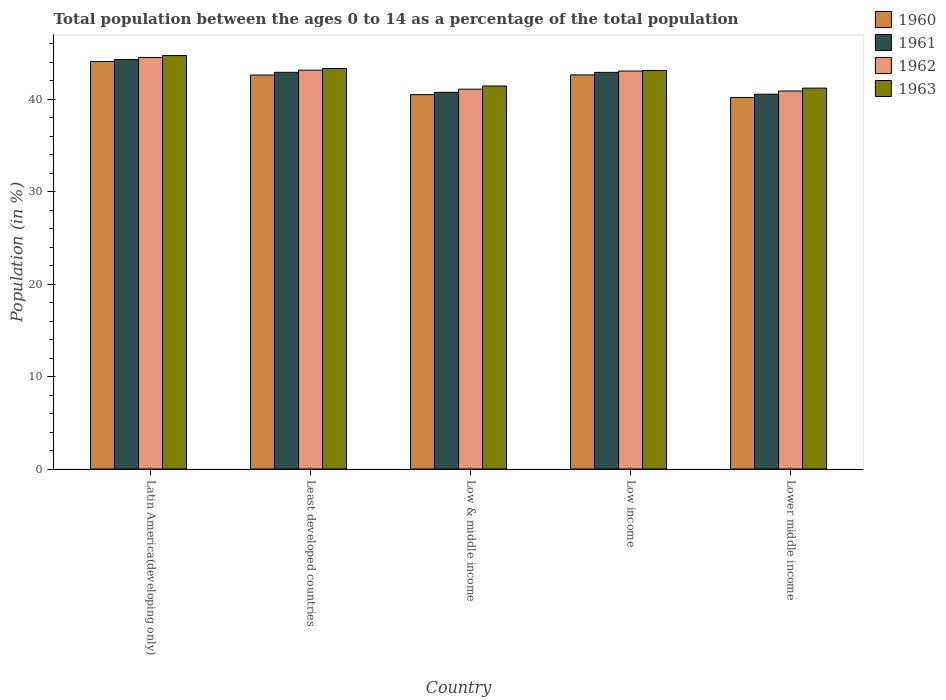How many different coloured bars are there?
Offer a very short reply. 4. What is the label of the 3rd group of bars from the left?
Ensure brevity in your answer.  Low & middle income. What is the percentage of the population ages 0 to 14 in 1963 in Least developed countries?
Provide a short and direct response. 43.34. Across all countries, what is the maximum percentage of the population ages 0 to 14 in 1963?
Your answer should be very brief. 44.74. Across all countries, what is the minimum percentage of the population ages 0 to 14 in 1962?
Ensure brevity in your answer.  40.9. In which country was the percentage of the population ages 0 to 14 in 1961 maximum?
Offer a very short reply. Latin America(developing only). In which country was the percentage of the population ages 0 to 14 in 1962 minimum?
Provide a succinct answer. Lower middle income. What is the total percentage of the population ages 0 to 14 in 1960 in the graph?
Your answer should be very brief. 210.1. What is the difference between the percentage of the population ages 0 to 14 in 1963 in Low & middle income and that in Lower middle income?
Your response must be concise. 0.23. What is the difference between the percentage of the population ages 0 to 14 in 1962 in Low & middle income and the percentage of the population ages 0 to 14 in 1963 in Least developed countries?
Your answer should be compact. -2.24. What is the average percentage of the population ages 0 to 14 in 1963 per country?
Give a very brief answer. 42.77. What is the difference between the percentage of the population ages 0 to 14 of/in 1961 and percentage of the population ages 0 to 14 of/in 1960 in Low income?
Ensure brevity in your answer.  0.27. In how many countries, is the percentage of the population ages 0 to 14 in 1962 greater than 18?
Ensure brevity in your answer.  5. What is the ratio of the percentage of the population ages 0 to 14 in 1963 in Latin America(developing only) to that in Low & middle income?
Keep it short and to the point. 1.08. Is the percentage of the population ages 0 to 14 in 1963 in Latin America(developing only) less than that in Least developed countries?
Offer a very short reply. No. What is the difference between the highest and the second highest percentage of the population ages 0 to 14 in 1961?
Provide a short and direct response. -1.38. What is the difference between the highest and the lowest percentage of the population ages 0 to 14 in 1961?
Give a very brief answer. 3.75. In how many countries, is the percentage of the population ages 0 to 14 in 1961 greater than the average percentage of the population ages 0 to 14 in 1961 taken over all countries?
Provide a short and direct response. 3. Is the sum of the percentage of the population ages 0 to 14 in 1963 in Least developed countries and Low income greater than the maximum percentage of the population ages 0 to 14 in 1962 across all countries?
Give a very brief answer. Yes. What does the 1st bar from the left in Lower middle income represents?
Your answer should be compact. 1960. What does the 2nd bar from the right in Low income represents?
Offer a very short reply. 1962. How many bars are there?
Make the answer very short. 20. How many countries are there in the graph?
Ensure brevity in your answer.  5. Does the graph contain any zero values?
Ensure brevity in your answer.  No. What is the title of the graph?
Your answer should be very brief. Total population between the ages 0 to 14 as a percentage of the total population. What is the label or title of the X-axis?
Your response must be concise. Country. What is the Population (in %) in 1960 in Latin America(developing only)?
Provide a succinct answer. 44.1. What is the Population (in %) in 1961 in Latin America(developing only)?
Your response must be concise. 44.31. What is the Population (in %) of 1962 in Latin America(developing only)?
Keep it short and to the point. 44.54. What is the Population (in %) of 1963 in Latin America(developing only)?
Your answer should be very brief. 44.74. What is the Population (in %) of 1960 in Least developed countries?
Ensure brevity in your answer.  42.63. What is the Population (in %) in 1961 in Least developed countries?
Your answer should be very brief. 42.93. What is the Population (in %) of 1962 in Least developed countries?
Your answer should be very brief. 43.16. What is the Population (in %) of 1963 in Least developed countries?
Provide a succinct answer. 43.34. What is the Population (in %) of 1960 in Low & middle income?
Keep it short and to the point. 40.51. What is the Population (in %) of 1961 in Low & middle income?
Offer a very short reply. 40.76. What is the Population (in %) in 1962 in Low & middle income?
Your answer should be compact. 41.1. What is the Population (in %) of 1963 in Low & middle income?
Keep it short and to the point. 41.45. What is the Population (in %) of 1960 in Low income?
Make the answer very short. 42.65. What is the Population (in %) in 1961 in Low income?
Offer a very short reply. 42.92. What is the Population (in %) in 1962 in Low income?
Give a very brief answer. 43.06. What is the Population (in %) in 1963 in Low income?
Ensure brevity in your answer.  43.12. What is the Population (in %) of 1960 in Lower middle income?
Your answer should be very brief. 40.21. What is the Population (in %) of 1961 in Lower middle income?
Make the answer very short. 40.56. What is the Population (in %) of 1962 in Lower middle income?
Make the answer very short. 40.9. What is the Population (in %) of 1963 in Lower middle income?
Make the answer very short. 41.22. Across all countries, what is the maximum Population (in %) in 1960?
Provide a succinct answer. 44.1. Across all countries, what is the maximum Population (in %) of 1961?
Make the answer very short. 44.31. Across all countries, what is the maximum Population (in %) of 1962?
Your answer should be compact. 44.54. Across all countries, what is the maximum Population (in %) of 1963?
Your answer should be very brief. 44.74. Across all countries, what is the minimum Population (in %) of 1960?
Your answer should be very brief. 40.21. Across all countries, what is the minimum Population (in %) of 1961?
Provide a short and direct response. 40.56. Across all countries, what is the minimum Population (in %) of 1962?
Ensure brevity in your answer.  40.9. Across all countries, what is the minimum Population (in %) of 1963?
Offer a terse response. 41.22. What is the total Population (in %) in 1960 in the graph?
Your response must be concise. 210.1. What is the total Population (in %) of 1961 in the graph?
Provide a short and direct response. 211.47. What is the total Population (in %) of 1962 in the graph?
Provide a succinct answer. 212.76. What is the total Population (in %) in 1963 in the graph?
Provide a succinct answer. 213.87. What is the difference between the Population (in %) of 1960 in Latin America(developing only) and that in Least developed countries?
Keep it short and to the point. 1.47. What is the difference between the Population (in %) of 1961 in Latin America(developing only) and that in Least developed countries?
Give a very brief answer. 1.38. What is the difference between the Population (in %) in 1962 in Latin America(developing only) and that in Least developed countries?
Offer a terse response. 1.38. What is the difference between the Population (in %) in 1963 in Latin America(developing only) and that in Least developed countries?
Provide a short and direct response. 1.4. What is the difference between the Population (in %) in 1960 in Latin America(developing only) and that in Low & middle income?
Offer a terse response. 3.59. What is the difference between the Population (in %) of 1961 in Latin America(developing only) and that in Low & middle income?
Give a very brief answer. 3.55. What is the difference between the Population (in %) of 1962 in Latin America(developing only) and that in Low & middle income?
Your answer should be compact. 3.43. What is the difference between the Population (in %) of 1963 in Latin America(developing only) and that in Low & middle income?
Provide a succinct answer. 3.3. What is the difference between the Population (in %) of 1960 in Latin America(developing only) and that in Low income?
Your response must be concise. 1.45. What is the difference between the Population (in %) in 1961 in Latin America(developing only) and that in Low income?
Your answer should be very brief. 1.39. What is the difference between the Population (in %) of 1962 in Latin America(developing only) and that in Low income?
Provide a short and direct response. 1.48. What is the difference between the Population (in %) of 1963 in Latin America(developing only) and that in Low income?
Provide a succinct answer. 1.62. What is the difference between the Population (in %) in 1960 in Latin America(developing only) and that in Lower middle income?
Give a very brief answer. 3.89. What is the difference between the Population (in %) of 1961 in Latin America(developing only) and that in Lower middle income?
Your answer should be compact. 3.75. What is the difference between the Population (in %) in 1962 in Latin America(developing only) and that in Lower middle income?
Offer a terse response. 3.63. What is the difference between the Population (in %) in 1963 in Latin America(developing only) and that in Lower middle income?
Make the answer very short. 3.52. What is the difference between the Population (in %) in 1960 in Least developed countries and that in Low & middle income?
Offer a very short reply. 2.12. What is the difference between the Population (in %) of 1961 in Least developed countries and that in Low & middle income?
Your answer should be compact. 2.17. What is the difference between the Population (in %) of 1962 in Least developed countries and that in Low & middle income?
Your answer should be compact. 2.06. What is the difference between the Population (in %) of 1963 in Least developed countries and that in Low & middle income?
Provide a succinct answer. 1.9. What is the difference between the Population (in %) in 1960 in Least developed countries and that in Low income?
Your answer should be compact. -0.01. What is the difference between the Population (in %) of 1961 in Least developed countries and that in Low income?
Keep it short and to the point. 0.01. What is the difference between the Population (in %) in 1962 in Least developed countries and that in Low income?
Make the answer very short. 0.1. What is the difference between the Population (in %) of 1963 in Least developed countries and that in Low income?
Your answer should be very brief. 0.22. What is the difference between the Population (in %) in 1960 in Least developed countries and that in Lower middle income?
Offer a very short reply. 2.43. What is the difference between the Population (in %) of 1961 in Least developed countries and that in Lower middle income?
Give a very brief answer. 2.37. What is the difference between the Population (in %) of 1962 in Least developed countries and that in Lower middle income?
Ensure brevity in your answer.  2.26. What is the difference between the Population (in %) in 1963 in Least developed countries and that in Lower middle income?
Ensure brevity in your answer.  2.13. What is the difference between the Population (in %) in 1960 in Low & middle income and that in Low income?
Give a very brief answer. -2.14. What is the difference between the Population (in %) in 1961 in Low & middle income and that in Low income?
Your answer should be very brief. -2.16. What is the difference between the Population (in %) in 1962 in Low & middle income and that in Low income?
Provide a short and direct response. -1.96. What is the difference between the Population (in %) in 1963 in Low & middle income and that in Low income?
Make the answer very short. -1.68. What is the difference between the Population (in %) in 1960 in Low & middle income and that in Lower middle income?
Provide a short and direct response. 0.3. What is the difference between the Population (in %) of 1961 in Low & middle income and that in Lower middle income?
Your response must be concise. 0.2. What is the difference between the Population (in %) in 1962 in Low & middle income and that in Lower middle income?
Offer a terse response. 0.2. What is the difference between the Population (in %) in 1963 in Low & middle income and that in Lower middle income?
Make the answer very short. 0.23. What is the difference between the Population (in %) in 1960 in Low income and that in Lower middle income?
Provide a short and direct response. 2.44. What is the difference between the Population (in %) of 1961 in Low income and that in Lower middle income?
Give a very brief answer. 2.36. What is the difference between the Population (in %) of 1962 in Low income and that in Lower middle income?
Offer a very short reply. 2.16. What is the difference between the Population (in %) of 1963 in Low income and that in Lower middle income?
Your response must be concise. 1.91. What is the difference between the Population (in %) of 1960 in Latin America(developing only) and the Population (in %) of 1961 in Least developed countries?
Offer a terse response. 1.17. What is the difference between the Population (in %) in 1960 in Latin America(developing only) and the Population (in %) in 1962 in Least developed countries?
Provide a short and direct response. 0.94. What is the difference between the Population (in %) of 1960 in Latin America(developing only) and the Population (in %) of 1963 in Least developed countries?
Make the answer very short. 0.76. What is the difference between the Population (in %) of 1961 in Latin America(developing only) and the Population (in %) of 1962 in Least developed countries?
Make the answer very short. 1.15. What is the difference between the Population (in %) in 1961 in Latin America(developing only) and the Population (in %) in 1963 in Least developed countries?
Give a very brief answer. 0.97. What is the difference between the Population (in %) of 1962 in Latin America(developing only) and the Population (in %) of 1963 in Least developed countries?
Your answer should be very brief. 1.19. What is the difference between the Population (in %) in 1960 in Latin America(developing only) and the Population (in %) in 1961 in Low & middle income?
Your response must be concise. 3.34. What is the difference between the Population (in %) of 1960 in Latin America(developing only) and the Population (in %) of 1962 in Low & middle income?
Your answer should be very brief. 3. What is the difference between the Population (in %) of 1960 in Latin America(developing only) and the Population (in %) of 1963 in Low & middle income?
Your answer should be compact. 2.66. What is the difference between the Population (in %) in 1961 in Latin America(developing only) and the Population (in %) in 1962 in Low & middle income?
Provide a short and direct response. 3.2. What is the difference between the Population (in %) of 1961 in Latin America(developing only) and the Population (in %) of 1963 in Low & middle income?
Make the answer very short. 2.86. What is the difference between the Population (in %) of 1962 in Latin America(developing only) and the Population (in %) of 1963 in Low & middle income?
Your answer should be very brief. 3.09. What is the difference between the Population (in %) of 1960 in Latin America(developing only) and the Population (in %) of 1961 in Low income?
Ensure brevity in your answer.  1.18. What is the difference between the Population (in %) in 1960 in Latin America(developing only) and the Population (in %) in 1962 in Low income?
Your response must be concise. 1.04. What is the difference between the Population (in %) of 1960 in Latin America(developing only) and the Population (in %) of 1963 in Low income?
Ensure brevity in your answer.  0.98. What is the difference between the Population (in %) in 1961 in Latin America(developing only) and the Population (in %) in 1962 in Low income?
Your answer should be compact. 1.25. What is the difference between the Population (in %) of 1961 in Latin America(developing only) and the Population (in %) of 1963 in Low income?
Offer a terse response. 1.18. What is the difference between the Population (in %) of 1962 in Latin America(developing only) and the Population (in %) of 1963 in Low income?
Offer a very short reply. 1.41. What is the difference between the Population (in %) of 1960 in Latin America(developing only) and the Population (in %) of 1961 in Lower middle income?
Offer a terse response. 3.54. What is the difference between the Population (in %) of 1960 in Latin America(developing only) and the Population (in %) of 1962 in Lower middle income?
Your response must be concise. 3.2. What is the difference between the Population (in %) of 1960 in Latin America(developing only) and the Population (in %) of 1963 in Lower middle income?
Make the answer very short. 2.89. What is the difference between the Population (in %) of 1961 in Latin America(developing only) and the Population (in %) of 1962 in Lower middle income?
Your response must be concise. 3.4. What is the difference between the Population (in %) in 1961 in Latin America(developing only) and the Population (in %) in 1963 in Lower middle income?
Keep it short and to the point. 3.09. What is the difference between the Population (in %) of 1962 in Latin America(developing only) and the Population (in %) of 1963 in Lower middle income?
Make the answer very short. 3.32. What is the difference between the Population (in %) in 1960 in Least developed countries and the Population (in %) in 1961 in Low & middle income?
Offer a terse response. 1.87. What is the difference between the Population (in %) in 1960 in Least developed countries and the Population (in %) in 1962 in Low & middle income?
Your answer should be compact. 1.53. What is the difference between the Population (in %) in 1960 in Least developed countries and the Population (in %) in 1963 in Low & middle income?
Make the answer very short. 1.19. What is the difference between the Population (in %) of 1961 in Least developed countries and the Population (in %) of 1962 in Low & middle income?
Offer a terse response. 1.82. What is the difference between the Population (in %) of 1961 in Least developed countries and the Population (in %) of 1963 in Low & middle income?
Your response must be concise. 1.48. What is the difference between the Population (in %) in 1962 in Least developed countries and the Population (in %) in 1963 in Low & middle income?
Ensure brevity in your answer.  1.71. What is the difference between the Population (in %) of 1960 in Least developed countries and the Population (in %) of 1961 in Low income?
Keep it short and to the point. -0.29. What is the difference between the Population (in %) in 1960 in Least developed countries and the Population (in %) in 1962 in Low income?
Offer a very short reply. -0.43. What is the difference between the Population (in %) in 1960 in Least developed countries and the Population (in %) in 1963 in Low income?
Provide a succinct answer. -0.49. What is the difference between the Population (in %) in 1961 in Least developed countries and the Population (in %) in 1962 in Low income?
Offer a terse response. -0.13. What is the difference between the Population (in %) of 1961 in Least developed countries and the Population (in %) of 1963 in Low income?
Give a very brief answer. -0.2. What is the difference between the Population (in %) of 1962 in Least developed countries and the Population (in %) of 1963 in Low income?
Give a very brief answer. 0.04. What is the difference between the Population (in %) of 1960 in Least developed countries and the Population (in %) of 1961 in Lower middle income?
Ensure brevity in your answer.  2.08. What is the difference between the Population (in %) of 1960 in Least developed countries and the Population (in %) of 1962 in Lower middle income?
Provide a short and direct response. 1.73. What is the difference between the Population (in %) of 1960 in Least developed countries and the Population (in %) of 1963 in Lower middle income?
Offer a very short reply. 1.42. What is the difference between the Population (in %) in 1961 in Least developed countries and the Population (in %) in 1962 in Lower middle income?
Offer a very short reply. 2.02. What is the difference between the Population (in %) in 1961 in Least developed countries and the Population (in %) in 1963 in Lower middle income?
Offer a very short reply. 1.71. What is the difference between the Population (in %) of 1962 in Least developed countries and the Population (in %) of 1963 in Lower middle income?
Your answer should be compact. 1.94. What is the difference between the Population (in %) of 1960 in Low & middle income and the Population (in %) of 1961 in Low income?
Your answer should be very brief. -2.41. What is the difference between the Population (in %) in 1960 in Low & middle income and the Population (in %) in 1962 in Low income?
Ensure brevity in your answer.  -2.55. What is the difference between the Population (in %) in 1960 in Low & middle income and the Population (in %) in 1963 in Low income?
Make the answer very short. -2.61. What is the difference between the Population (in %) in 1961 in Low & middle income and the Population (in %) in 1962 in Low income?
Offer a very short reply. -2.3. What is the difference between the Population (in %) in 1961 in Low & middle income and the Population (in %) in 1963 in Low income?
Provide a succinct answer. -2.36. What is the difference between the Population (in %) of 1962 in Low & middle income and the Population (in %) of 1963 in Low income?
Provide a short and direct response. -2.02. What is the difference between the Population (in %) in 1960 in Low & middle income and the Population (in %) in 1961 in Lower middle income?
Ensure brevity in your answer.  -0.05. What is the difference between the Population (in %) in 1960 in Low & middle income and the Population (in %) in 1962 in Lower middle income?
Offer a terse response. -0.39. What is the difference between the Population (in %) in 1960 in Low & middle income and the Population (in %) in 1963 in Lower middle income?
Keep it short and to the point. -0.7. What is the difference between the Population (in %) in 1961 in Low & middle income and the Population (in %) in 1962 in Lower middle income?
Your answer should be compact. -0.14. What is the difference between the Population (in %) of 1961 in Low & middle income and the Population (in %) of 1963 in Lower middle income?
Offer a terse response. -0.45. What is the difference between the Population (in %) in 1962 in Low & middle income and the Population (in %) in 1963 in Lower middle income?
Provide a succinct answer. -0.11. What is the difference between the Population (in %) in 1960 in Low income and the Population (in %) in 1961 in Lower middle income?
Offer a terse response. 2.09. What is the difference between the Population (in %) of 1960 in Low income and the Population (in %) of 1962 in Lower middle income?
Provide a succinct answer. 1.74. What is the difference between the Population (in %) of 1960 in Low income and the Population (in %) of 1963 in Lower middle income?
Your response must be concise. 1.43. What is the difference between the Population (in %) in 1961 in Low income and the Population (in %) in 1962 in Lower middle income?
Offer a terse response. 2.02. What is the difference between the Population (in %) in 1961 in Low income and the Population (in %) in 1963 in Lower middle income?
Your response must be concise. 1.7. What is the difference between the Population (in %) in 1962 in Low income and the Population (in %) in 1963 in Lower middle income?
Give a very brief answer. 1.84. What is the average Population (in %) in 1960 per country?
Provide a short and direct response. 42.02. What is the average Population (in %) in 1961 per country?
Keep it short and to the point. 42.29. What is the average Population (in %) in 1962 per country?
Your answer should be very brief. 42.55. What is the average Population (in %) of 1963 per country?
Keep it short and to the point. 42.77. What is the difference between the Population (in %) of 1960 and Population (in %) of 1961 in Latin America(developing only)?
Provide a short and direct response. -0.21. What is the difference between the Population (in %) of 1960 and Population (in %) of 1962 in Latin America(developing only)?
Provide a short and direct response. -0.43. What is the difference between the Population (in %) of 1960 and Population (in %) of 1963 in Latin America(developing only)?
Provide a short and direct response. -0.64. What is the difference between the Population (in %) of 1961 and Population (in %) of 1962 in Latin America(developing only)?
Your response must be concise. -0.23. What is the difference between the Population (in %) of 1961 and Population (in %) of 1963 in Latin America(developing only)?
Offer a terse response. -0.43. What is the difference between the Population (in %) of 1962 and Population (in %) of 1963 in Latin America(developing only)?
Offer a very short reply. -0.2. What is the difference between the Population (in %) of 1960 and Population (in %) of 1961 in Least developed countries?
Provide a short and direct response. -0.29. What is the difference between the Population (in %) in 1960 and Population (in %) in 1962 in Least developed countries?
Make the answer very short. -0.53. What is the difference between the Population (in %) of 1960 and Population (in %) of 1963 in Least developed countries?
Provide a short and direct response. -0.71. What is the difference between the Population (in %) in 1961 and Population (in %) in 1962 in Least developed countries?
Your response must be concise. -0.23. What is the difference between the Population (in %) of 1961 and Population (in %) of 1963 in Least developed countries?
Give a very brief answer. -0.41. What is the difference between the Population (in %) in 1962 and Population (in %) in 1963 in Least developed countries?
Ensure brevity in your answer.  -0.18. What is the difference between the Population (in %) in 1960 and Population (in %) in 1961 in Low & middle income?
Provide a short and direct response. -0.25. What is the difference between the Population (in %) in 1960 and Population (in %) in 1962 in Low & middle income?
Your response must be concise. -0.59. What is the difference between the Population (in %) in 1960 and Population (in %) in 1963 in Low & middle income?
Provide a short and direct response. -0.93. What is the difference between the Population (in %) in 1961 and Population (in %) in 1962 in Low & middle income?
Your response must be concise. -0.34. What is the difference between the Population (in %) in 1961 and Population (in %) in 1963 in Low & middle income?
Provide a short and direct response. -0.68. What is the difference between the Population (in %) of 1962 and Population (in %) of 1963 in Low & middle income?
Your response must be concise. -0.34. What is the difference between the Population (in %) in 1960 and Population (in %) in 1961 in Low income?
Keep it short and to the point. -0.27. What is the difference between the Population (in %) of 1960 and Population (in %) of 1962 in Low income?
Make the answer very short. -0.41. What is the difference between the Population (in %) of 1960 and Population (in %) of 1963 in Low income?
Ensure brevity in your answer.  -0.48. What is the difference between the Population (in %) in 1961 and Population (in %) in 1962 in Low income?
Offer a terse response. -0.14. What is the difference between the Population (in %) of 1961 and Population (in %) of 1963 in Low income?
Offer a terse response. -0.2. What is the difference between the Population (in %) in 1962 and Population (in %) in 1963 in Low income?
Provide a short and direct response. -0.06. What is the difference between the Population (in %) of 1960 and Population (in %) of 1961 in Lower middle income?
Your answer should be compact. -0.35. What is the difference between the Population (in %) of 1960 and Population (in %) of 1962 in Lower middle income?
Provide a short and direct response. -0.7. What is the difference between the Population (in %) in 1960 and Population (in %) in 1963 in Lower middle income?
Your answer should be very brief. -1.01. What is the difference between the Population (in %) of 1961 and Population (in %) of 1962 in Lower middle income?
Your answer should be very brief. -0.35. What is the difference between the Population (in %) of 1961 and Population (in %) of 1963 in Lower middle income?
Keep it short and to the point. -0.66. What is the difference between the Population (in %) of 1962 and Population (in %) of 1963 in Lower middle income?
Offer a terse response. -0.31. What is the ratio of the Population (in %) in 1960 in Latin America(developing only) to that in Least developed countries?
Provide a short and direct response. 1.03. What is the ratio of the Population (in %) of 1961 in Latin America(developing only) to that in Least developed countries?
Your answer should be very brief. 1.03. What is the ratio of the Population (in %) in 1962 in Latin America(developing only) to that in Least developed countries?
Your response must be concise. 1.03. What is the ratio of the Population (in %) of 1963 in Latin America(developing only) to that in Least developed countries?
Your answer should be compact. 1.03. What is the ratio of the Population (in %) in 1960 in Latin America(developing only) to that in Low & middle income?
Make the answer very short. 1.09. What is the ratio of the Population (in %) of 1961 in Latin America(developing only) to that in Low & middle income?
Your answer should be compact. 1.09. What is the ratio of the Population (in %) of 1962 in Latin America(developing only) to that in Low & middle income?
Provide a short and direct response. 1.08. What is the ratio of the Population (in %) in 1963 in Latin America(developing only) to that in Low & middle income?
Ensure brevity in your answer.  1.08. What is the ratio of the Population (in %) of 1960 in Latin America(developing only) to that in Low income?
Offer a very short reply. 1.03. What is the ratio of the Population (in %) of 1961 in Latin America(developing only) to that in Low income?
Your response must be concise. 1.03. What is the ratio of the Population (in %) of 1962 in Latin America(developing only) to that in Low income?
Give a very brief answer. 1.03. What is the ratio of the Population (in %) in 1963 in Latin America(developing only) to that in Low income?
Offer a very short reply. 1.04. What is the ratio of the Population (in %) in 1960 in Latin America(developing only) to that in Lower middle income?
Your response must be concise. 1.1. What is the ratio of the Population (in %) of 1961 in Latin America(developing only) to that in Lower middle income?
Your answer should be compact. 1.09. What is the ratio of the Population (in %) of 1962 in Latin America(developing only) to that in Lower middle income?
Your answer should be compact. 1.09. What is the ratio of the Population (in %) of 1963 in Latin America(developing only) to that in Lower middle income?
Give a very brief answer. 1.09. What is the ratio of the Population (in %) in 1960 in Least developed countries to that in Low & middle income?
Ensure brevity in your answer.  1.05. What is the ratio of the Population (in %) of 1961 in Least developed countries to that in Low & middle income?
Your response must be concise. 1.05. What is the ratio of the Population (in %) in 1962 in Least developed countries to that in Low & middle income?
Your response must be concise. 1.05. What is the ratio of the Population (in %) in 1963 in Least developed countries to that in Low & middle income?
Keep it short and to the point. 1.05. What is the ratio of the Population (in %) of 1963 in Least developed countries to that in Low income?
Keep it short and to the point. 1.01. What is the ratio of the Population (in %) in 1960 in Least developed countries to that in Lower middle income?
Give a very brief answer. 1.06. What is the ratio of the Population (in %) in 1961 in Least developed countries to that in Lower middle income?
Your answer should be compact. 1.06. What is the ratio of the Population (in %) in 1962 in Least developed countries to that in Lower middle income?
Make the answer very short. 1.06. What is the ratio of the Population (in %) of 1963 in Least developed countries to that in Lower middle income?
Your response must be concise. 1.05. What is the ratio of the Population (in %) of 1960 in Low & middle income to that in Low income?
Offer a terse response. 0.95. What is the ratio of the Population (in %) of 1961 in Low & middle income to that in Low income?
Your response must be concise. 0.95. What is the ratio of the Population (in %) of 1962 in Low & middle income to that in Low income?
Your answer should be very brief. 0.95. What is the ratio of the Population (in %) of 1963 in Low & middle income to that in Low income?
Your answer should be very brief. 0.96. What is the ratio of the Population (in %) of 1960 in Low & middle income to that in Lower middle income?
Your answer should be compact. 1.01. What is the ratio of the Population (in %) of 1963 in Low & middle income to that in Lower middle income?
Your response must be concise. 1.01. What is the ratio of the Population (in %) of 1960 in Low income to that in Lower middle income?
Provide a succinct answer. 1.06. What is the ratio of the Population (in %) in 1961 in Low income to that in Lower middle income?
Your answer should be compact. 1.06. What is the ratio of the Population (in %) of 1962 in Low income to that in Lower middle income?
Give a very brief answer. 1.05. What is the ratio of the Population (in %) in 1963 in Low income to that in Lower middle income?
Offer a very short reply. 1.05. What is the difference between the highest and the second highest Population (in %) in 1960?
Offer a very short reply. 1.45. What is the difference between the highest and the second highest Population (in %) in 1961?
Keep it short and to the point. 1.38. What is the difference between the highest and the second highest Population (in %) in 1962?
Make the answer very short. 1.38. What is the difference between the highest and the second highest Population (in %) in 1963?
Your response must be concise. 1.4. What is the difference between the highest and the lowest Population (in %) of 1960?
Give a very brief answer. 3.89. What is the difference between the highest and the lowest Population (in %) of 1961?
Provide a succinct answer. 3.75. What is the difference between the highest and the lowest Population (in %) in 1962?
Offer a very short reply. 3.63. What is the difference between the highest and the lowest Population (in %) in 1963?
Provide a short and direct response. 3.52. 